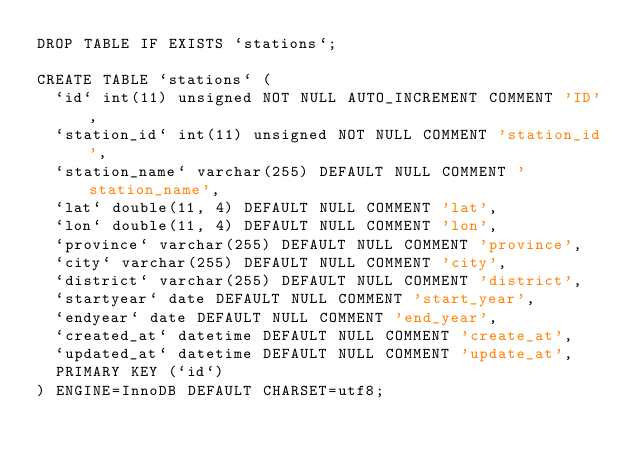<code> <loc_0><loc_0><loc_500><loc_500><_SQL_>DROP TABLE IF EXISTS `stations`;

CREATE TABLE `stations` (
  `id` int(11) unsigned NOT NULL AUTO_INCREMENT COMMENT 'ID',
  `station_id` int(11) unsigned NOT NULL COMMENT 'station_id',
  `station_name` varchar(255) DEFAULT NULL COMMENT 'station_name',
  `lat` double(11, 4) DEFAULT NULL COMMENT 'lat',
  `lon` double(11, 4) DEFAULT NULL COMMENT 'lon',
  `province` varchar(255) DEFAULT NULL COMMENT 'province',
  `city` varchar(255) DEFAULT NULL COMMENT 'city',
  `district` varchar(255) DEFAULT NULL COMMENT 'district',
  `startyear` date DEFAULT NULL COMMENT 'start_year',
  `endyear` date DEFAULT NULL COMMENT 'end_year',
  `created_at` datetime DEFAULT NULL COMMENT 'create_at',
  `updated_at` datetime DEFAULT NULL COMMENT 'update_at',
  PRIMARY KEY (`id`)
) ENGINE=InnoDB DEFAULT CHARSET=utf8;
</code> 